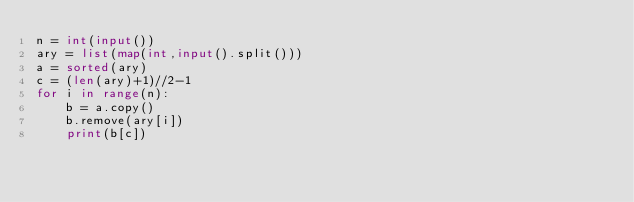Convert code to text. <code><loc_0><loc_0><loc_500><loc_500><_Python_>n = int(input())
ary = list(map(int,input().split()))
a = sorted(ary)
c = (len(ary)+1)//2-1
for i in range(n):
    b = a.copy()
    b.remove(ary[i])
    print(b[c])</code> 